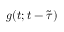<formula> <loc_0><loc_0><loc_500><loc_500>g ( t ; t - \tilde { \tau } )</formula> 